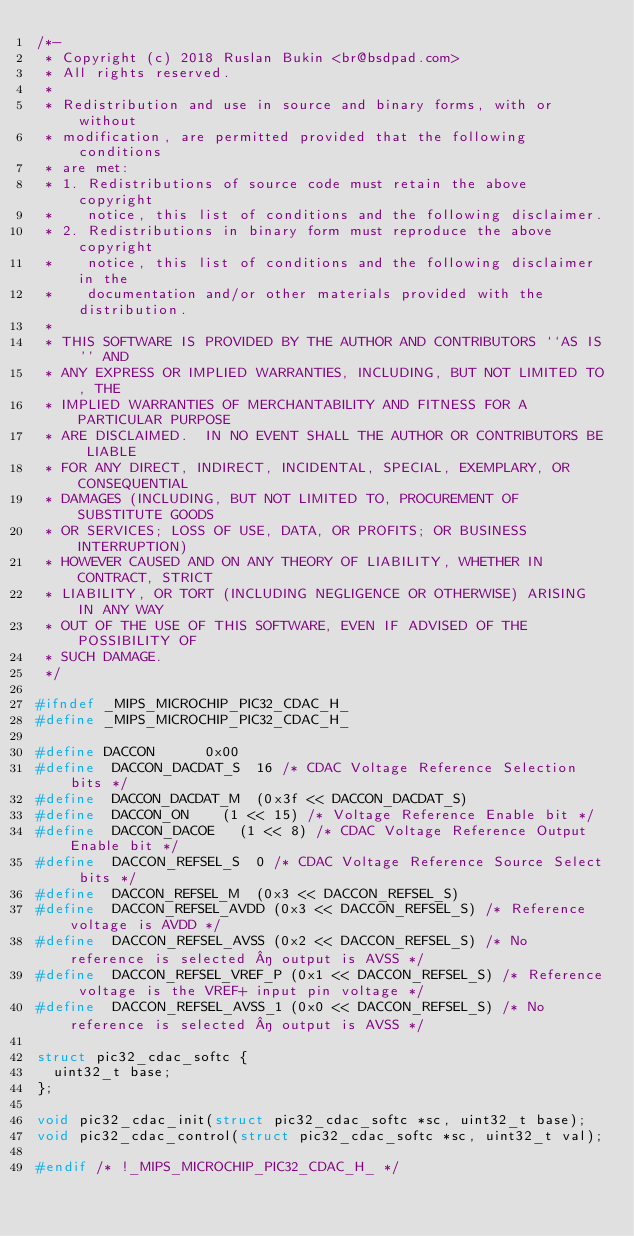<code> <loc_0><loc_0><loc_500><loc_500><_C_>/*-
 * Copyright (c) 2018 Ruslan Bukin <br@bsdpad.com>
 * All rights reserved.
 *
 * Redistribution and use in source and binary forms, with or without
 * modification, are permitted provided that the following conditions
 * are met:
 * 1. Redistributions of source code must retain the above copyright
 *    notice, this list of conditions and the following disclaimer.
 * 2. Redistributions in binary form must reproduce the above copyright
 *    notice, this list of conditions and the following disclaimer in the
 *    documentation and/or other materials provided with the distribution.
 *
 * THIS SOFTWARE IS PROVIDED BY THE AUTHOR AND CONTRIBUTORS ``AS IS'' AND
 * ANY EXPRESS OR IMPLIED WARRANTIES, INCLUDING, BUT NOT LIMITED TO, THE
 * IMPLIED WARRANTIES OF MERCHANTABILITY AND FITNESS FOR A PARTICULAR PURPOSE
 * ARE DISCLAIMED.  IN NO EVENT SHALL THE AUTHOR OR CONTRIBUTORS BE LIABLE
 * FOR ANY DIRECT, INDIRECT, INCIDENTAL, SPECIAL, EXEMPLARY, OR CONSEQUENTIAL
 * DAMAGES (INCLUDING, BUT NOT LIMITED TO, PROCUREMENT OF SUBSTITUTE GOODS
 * OR SERVICES; LOSS OF USE, DATA, OR PROFITS; OR BUSINESS INTERRUPTION)
 * HOWEVER CAUSED AND ON ANY THEORY OF LIABILITY, WHETHER IN CONTRACT, STRICT
 * LIABILITY, OR TORT (INCLUDING NEGLIGENCE OR OTHERWISE) ARISING IN ANY WAY
 * OUT OF THE USE OF THIS SOFTWARE, EVEN IF ADVISED OF THE POSSIBILITY OF
 * SUCH DAMAGE.
 */

#ifndef _MIPS_MICROCHIP_PIC32_CDAC_H_
#define	_MIPS_MICROCHIP_PIC32_CDAC_H_

#define	DACCON			0x00
#define	 DACCON_DACDAT_S	16 /* CDAC Voltage Reference Selection bits */
#define	 DACCON_DACDAT_M	(0x3f << DACCON_DACDAT_S)
#define	 DACCON_ON		(1 << 15) /* Voltage Reference Enable bit */
#define	 DACCON_DACOE		(1 << 8) /* CDAC Voltage Reference Output Enable bit */
#define	 DACCON_REFSEL_S	0 /* CDAC Voltage Reference Source Select bits */
#define	 DACCON_REFSEL_M	(0x3 << DACCON_REFSEL_S)
#define	 DACCON_REFSEL_AVDD	(0x3 << DACCON_REFSEL_S) /* Reference voltage is AVDD */
#define	 DACCON_REFSEL_AVSS	(0x2 << DACCON_REFSEL_S) /* No reference is selected ­ output is AVSS */
#define	 DACCON_REFSEL_VREF_P	(0x1 << DACCON_REFSEL_S) /* Reference voltage is the VREF+ input pin voltage */
#define	 DACCON_REFSEL_AVSS_1	(0x0 << DACCON_REFSEL_S) /* No reference is selected ­ output is AVSS */

struct pic32_cdac_softc {
	uint32_t base;
};

void pic32_cdac_init(struct pic32_cdac_softc *sc, uint32_t base);
void pic32_cdac_control(struct pic32_cdac_softc *sc, uint32_t val);

#endif /* !_MIPS_MICROCHIP_PIC32_CDAC_H_ */
</code> 